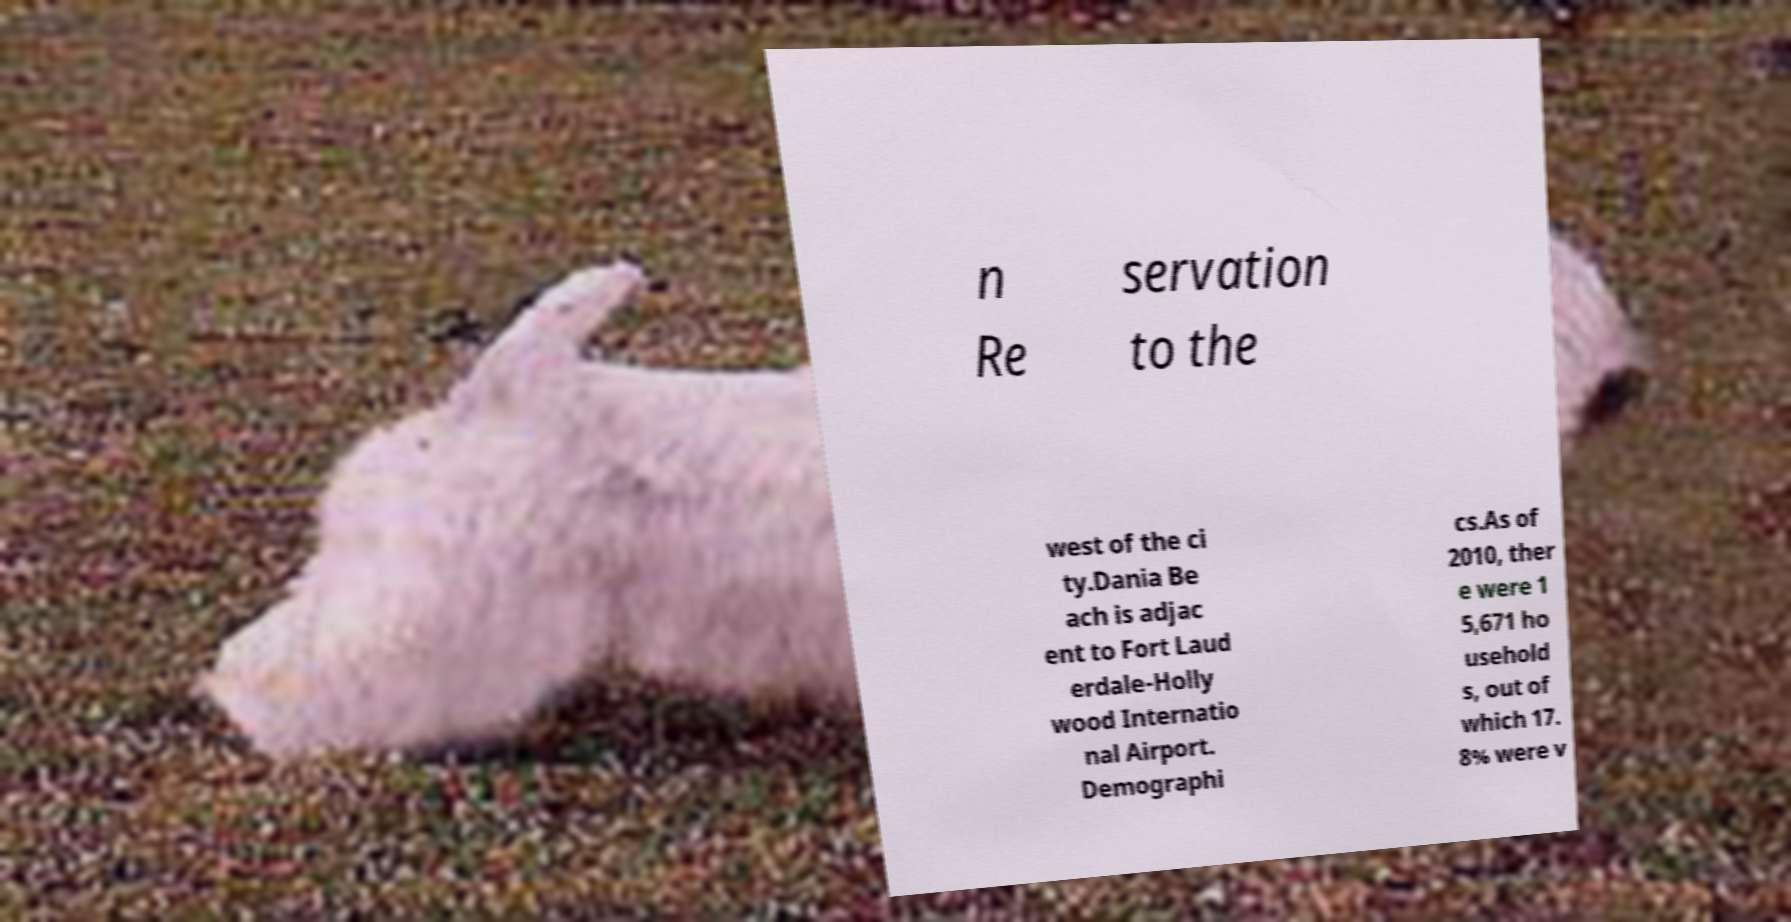What messages or text are displayed in this image? I need them in a readable, typed format. n Re servation to the west of the ci ty.Dania Be ach is adjac ent to Fort Laud erdale-Holly wood Internatio nal Airport. Demographi cs.As of 2010, ther e were 1 5,671 ho usehold s, out of which 17. 8% were v 